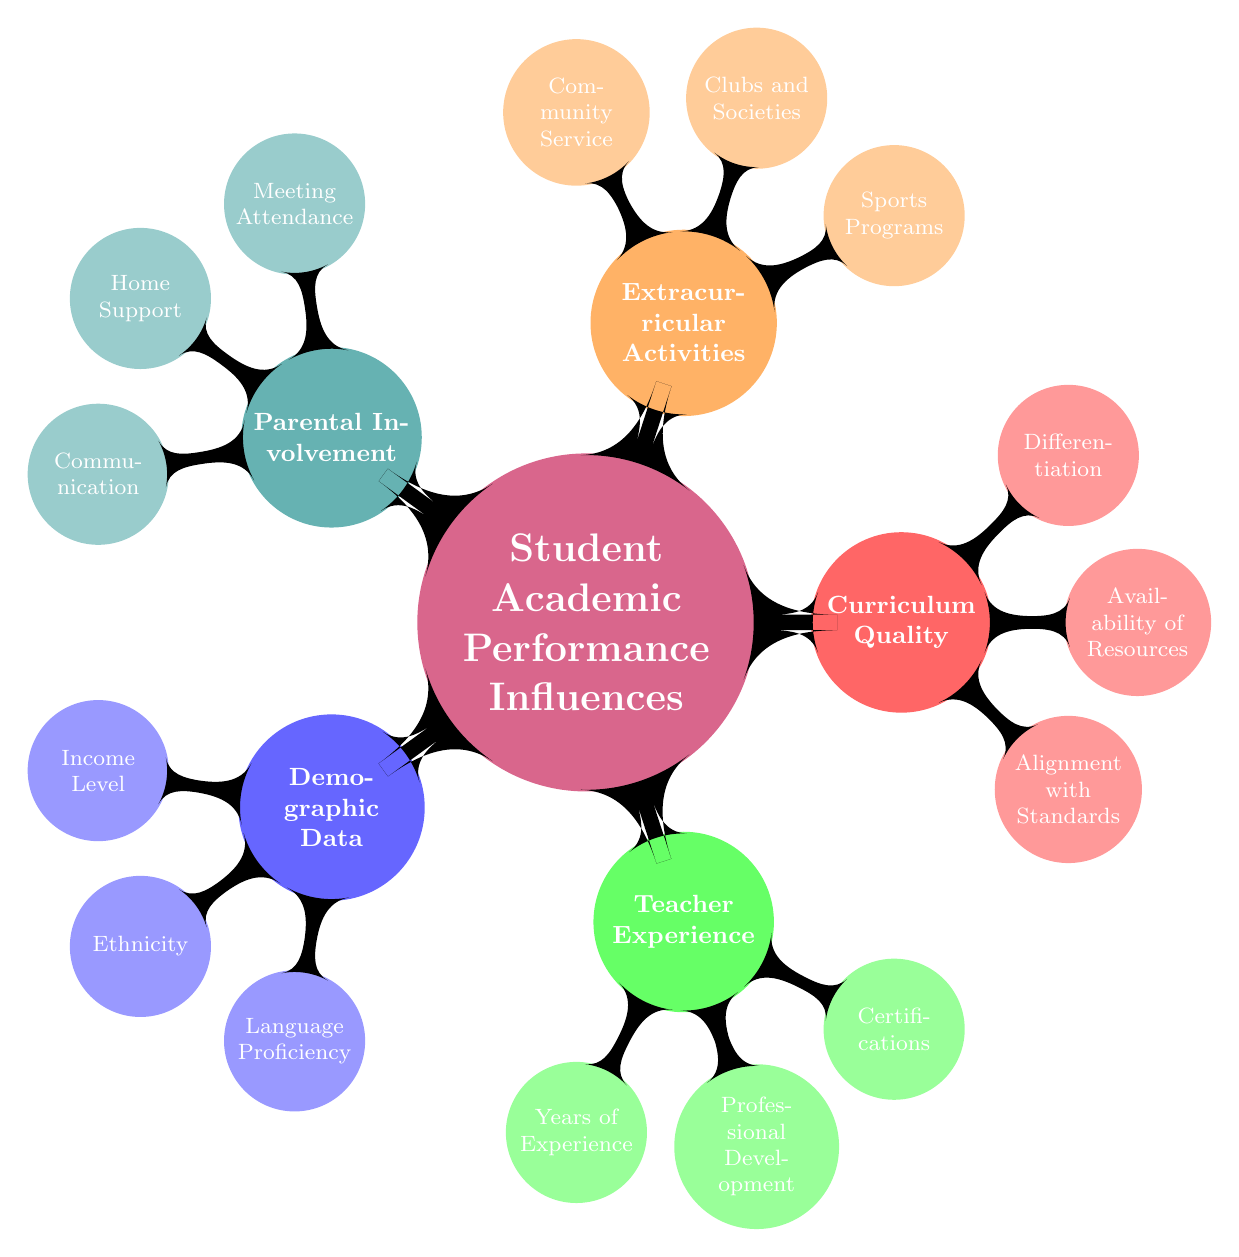What are the three categories under Demographic Data? Reviewing the "Demographic Data" node in the diagram, it lists three specific categories: "Income Level," "Ethnicity," and "Language Proficiency."
Answer: Income Level, Ethnicity, Language Proficiency How many years of experience are indicated in Teacher Experience? The "Years of Experience" node under "Teacher Experience" details three ranges: "1-3," "4-10," and "11+," which means there are three distinct categories listed.
Answer: 3 Which node is directly connected to Extracurricular Activities? The "Extracurricular Activities" node has three sub-nodes associated with it: "Sports Programs," "Clubs and Societies," and "Community Service." This indicates the variety of activities available under this influence category.
Answer: Sports Programs, Clubs and Societies, Community Service What does the "Professional Development" node include? Under "Teacher Experience," the "Professional Development" node lists workshops, conferences, and advanced degrees as its components. Therefore, the answer should encompass these three elements.
Answer: Workshops, Conferences, Advanced Degrees Which category contains the node "Communication"? Looking at the structure of the diagram, "Communication" is a sub-node under "Parental Involvement." Thus, this question can be directly answered by identifying the parent node of "Communication."
Answer: Parental Involvement How many influences are identified in the mind map? The central node "Student Academic Performance Influences" branches into five distinct categories: "Demographic Data," "Teacher Experience," "Curriculum Quality," "Extracurricular Activities," and "Parental Involvement." Counting these gives a total of five major influences.
Answer: 5 Which influence includes "Differentiation"? In the mind map, "Differentiation" is a sub-node listed under "Curriculum Quality." This requires looking at the connections starting from "Curriculum Quality" to identify where "Differentiation" belongs.
Answer: Curriculum Quality What type of support is suggested under Home Support? The "Home Support" node under "Parental Involvement" mentions three supports: "Homework Help," "Literacy Activities," and "Educational Expectations." This information tells what kind of support is highlighted.
Answer: Homework Help, Literacy Activities, Educational Expectations 